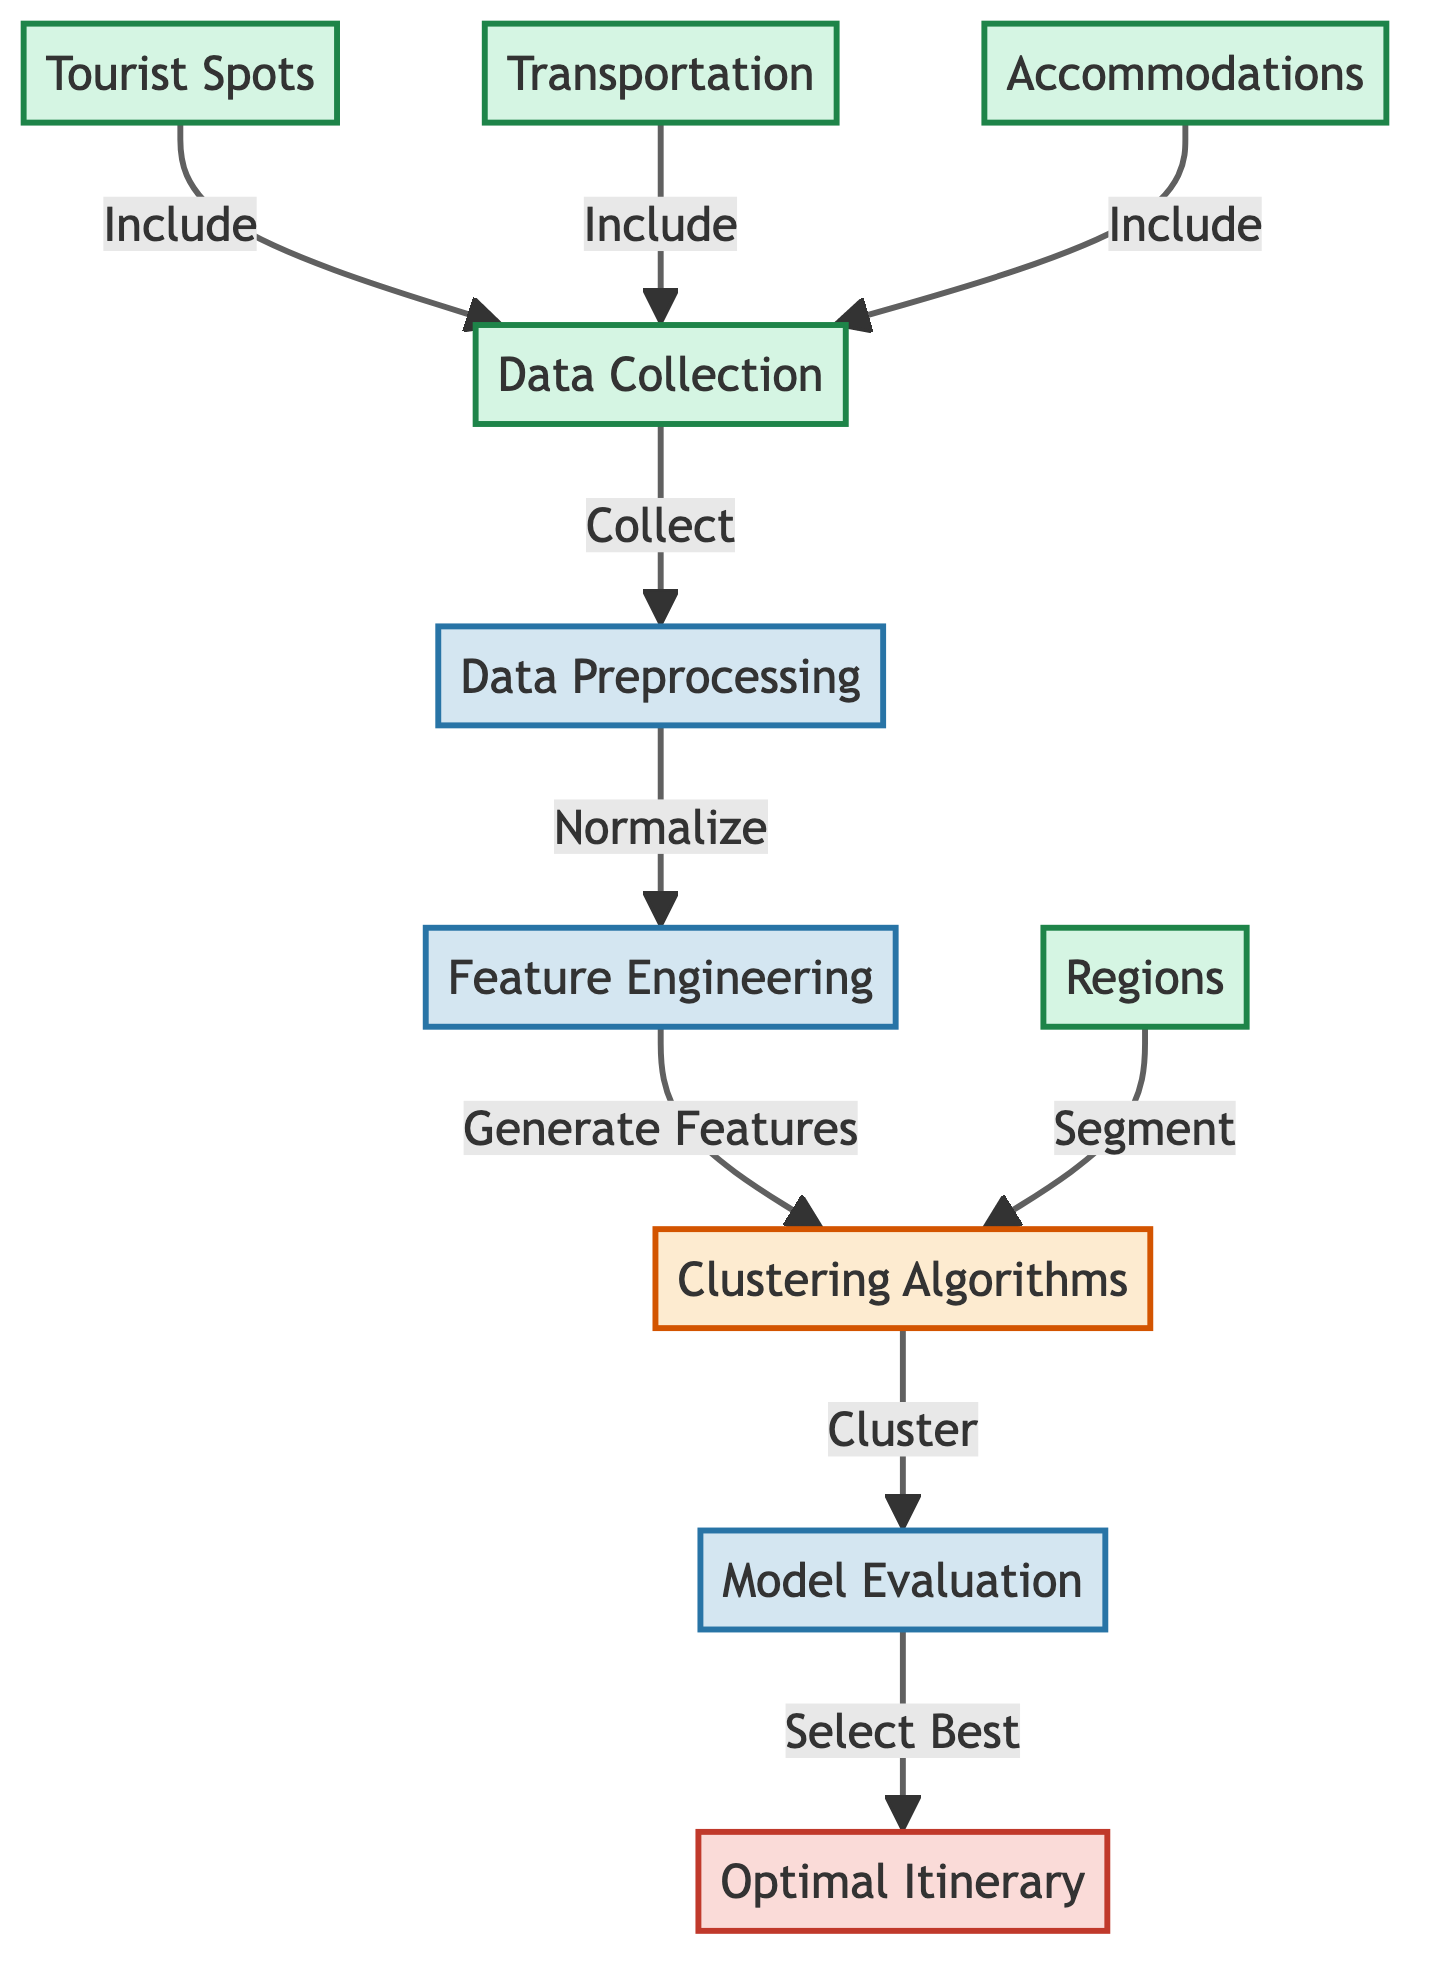What are the inputs for data collection? The diagram shows three arrows leading into the "Data Collection" node, indicating that "Tourist Spots," "Transportation," and "Accommodations" are the inputs for this process.
Answer: Tourist Spots, Transportation, Accommodations What is the first step after data collection? The diagram flows from the "Data Collection" node to the "Data Preprocessing" node, indicating that preprocessing is the immediate next step.
Answer: Data Preprocessing How many main processes are in the diagram? Counting the nodes classified as processes in the diagram reveals three: "Data Preprocessing," "Feature Engineering," and "Model Evaluation."
Answer: Three Which node comes after feature engineering? According to the flow of the diagram, the "Clustering Algorithms" node follows "Feature Engineering."
Answer: Clustering Algorithms What type of algorithms are utilized for itinerary planning? The diagram identifies algorithms used as "Clustering Algorithms," directly represented in the relevant process node.
Answer: Clustering Algorithms What is the output of the model evaluation? The diagram indicates an arrow pointing from "Model Evaluation" to the "Optimal Itinerary" node, signifying that the output is the optimal itinerary.
Answer: Optimal Itinerary How does the clustering process relate to regions? The diagram shows an arrow from "Regions" to the "Clustering Algorithms," indicating that regions are segmented during the clustering phase.
Answer: Segment Which step involves generating features? "Feature Engineering" is the step referred to in the diagram where features are generated after normalizing the data.
Answer: Feature Engineering What type of data sources are collected before preprocessing? The three data sources listed before preprocessing are "Tourist Spots," "Transportation," and "Accommodations," reflecting the types of data gathered.
Answer: Tourist Spots, Transportation, Accommodations 